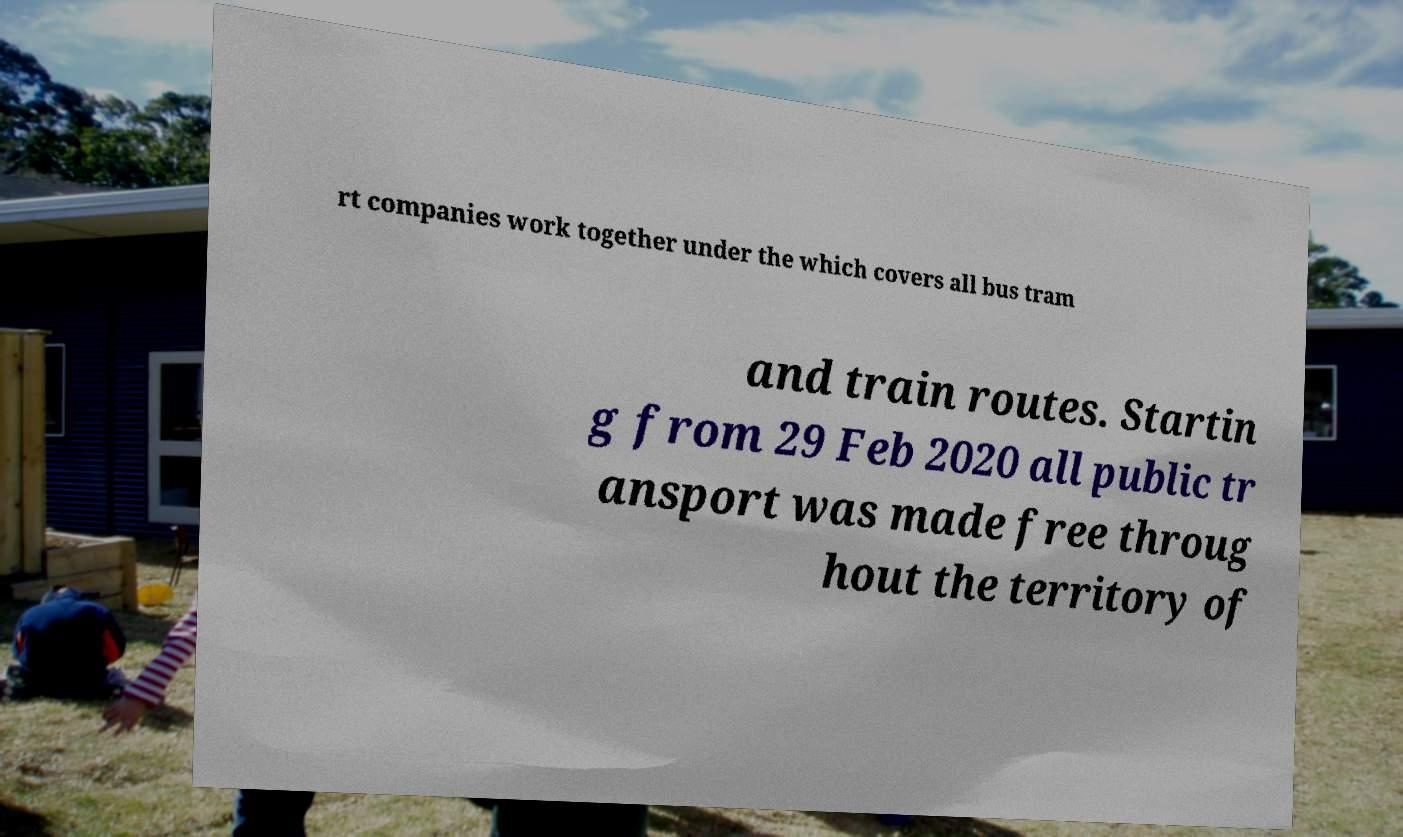Can you accurately transcribe the text from the provided image for me? rt companies work together under the which covers all bus tram and train routes. Startin g from 29 Feb 2020 all public tr ansport was made free throug hout the territory of 